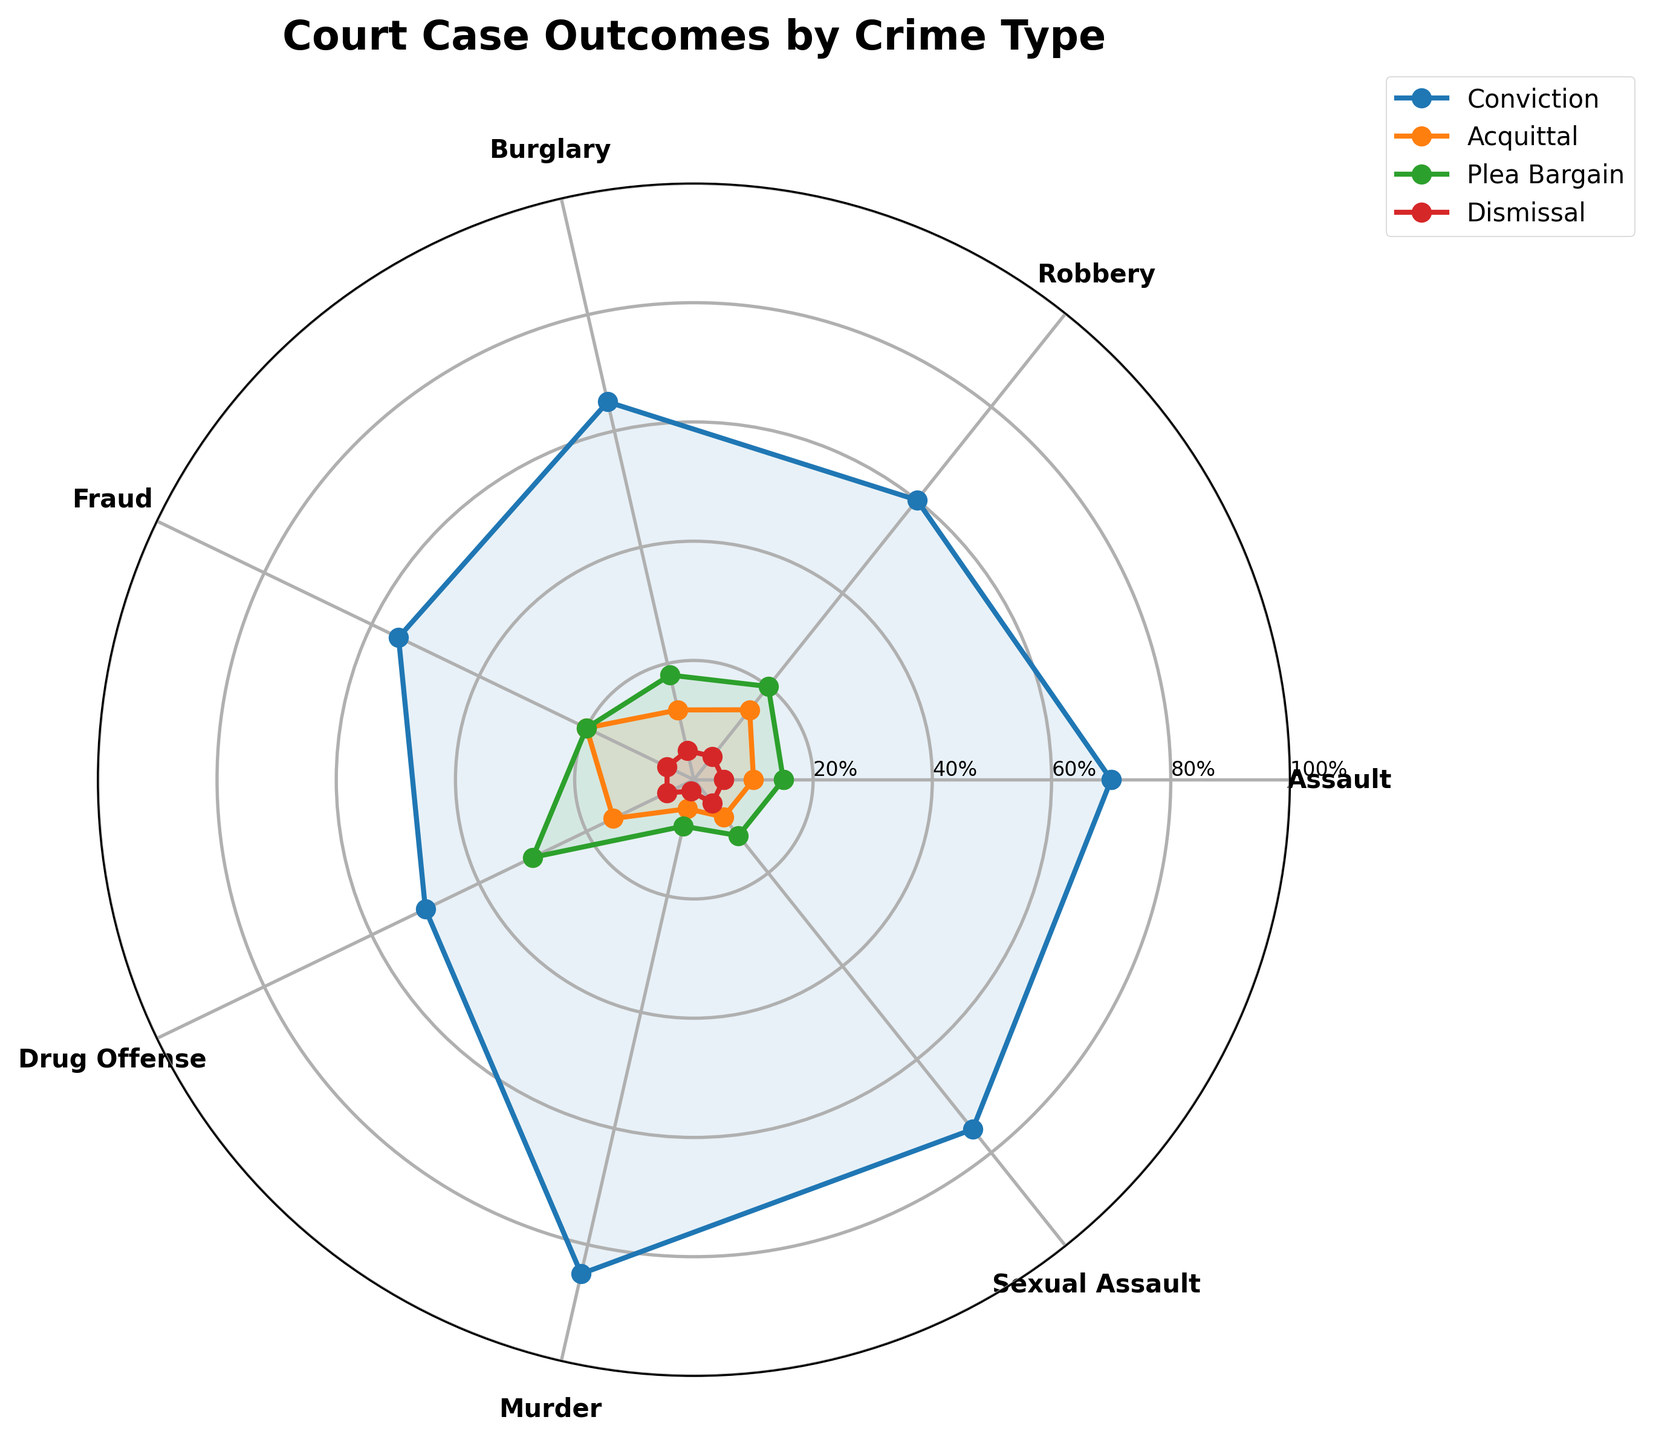Which crime type has the highest conviction rate? By examining the lengths of the Conviction line segment for each crime type, we can see that Murder has the highest conviction rate, at the top of the scale.
Answer: Murder How many types of crimes have a plea bargain rate exceeding 15%? By checking the Plea Bargain line segment, we see that Plea Bargain rates exceeding 15% are present in Drug Offense (30%), Burglary (18%), and Robbery (20%). Thus, there are three crime types.
Answer: 3 What is the median value of the Dismissal rates? We extract the Dismissal values (5, 5, 5, 5, 5, 2, 5), sort them (2, 5, 5, 5, 5, 5, 5), and identify the middle value, which is 5.
Answer: 5 Which outcome has the most uniform distribution across crime types? The distribution uniformity can be assessed by observing which outcome has the most similar lengths for all its segments. The Dismissal segments are mostly at 5% across almost all crime types, showing the most uniform distribution.
Answer: Dismissal For which crime type is the difference between conviction and acquittal rate the largest? By inspecting the differences for each crime type: Assault (70-10=60), Robbery (60-15=45), Burglary (65-12=53), Fraud (55-20=35), Drug Offense (50-15=35), Murder (85-5=80), and Sexual Assault (75-8=67), Murder has the largest difference (80).
Answer: Murder Which crime type has the lowest average rate for Conviction, Acquittal, Plea Bargain, and Dismissal? Calculating the averages: Assault (70+10+15+5)/4=25, Robbery (60+15+20+5)/4=25, Burglary (65+12+18+5)/4=25, Fraud (55+20+20+5)/4=25, Drug Offense (50+15+30+5)/4=25, Murder (85+5+8+2)/4=25, Sexual Assault (75+8+12+5)/4=25. All crimes have the same average rate of 25.
Answer: All crime types (same average rate of 25) Which two crime types have the closest plea bargain rates? By examining the Plea Bargain values, Fraud (20), Robbery (20), and Burglary (18) have the closest rates, with Fraud and Robbery being exactly equal.
Answer: Fraud and Robbery Which crime type has the least variability (range) in its outcome rates? Variability can be assessed by calculating the range for each crime type: Assault (70-5=65), Robbery (60-5=55), Burglary (65-5=60), Fraud (55-5=50), Drug Offense (50-5=45), Murder (85-2=83), Sexual Assault (75-5=70). Drug Offense has the smallest range (45).
Answer: Drug Offense Do any crime types have the same rate for two different outcomes? By checking values across outcomes for each crime type: none show any same rates except Fraud (where Conviction 55, Acquittal 20, Plea Bargain 20, Dismissal 5).
Answer: No 